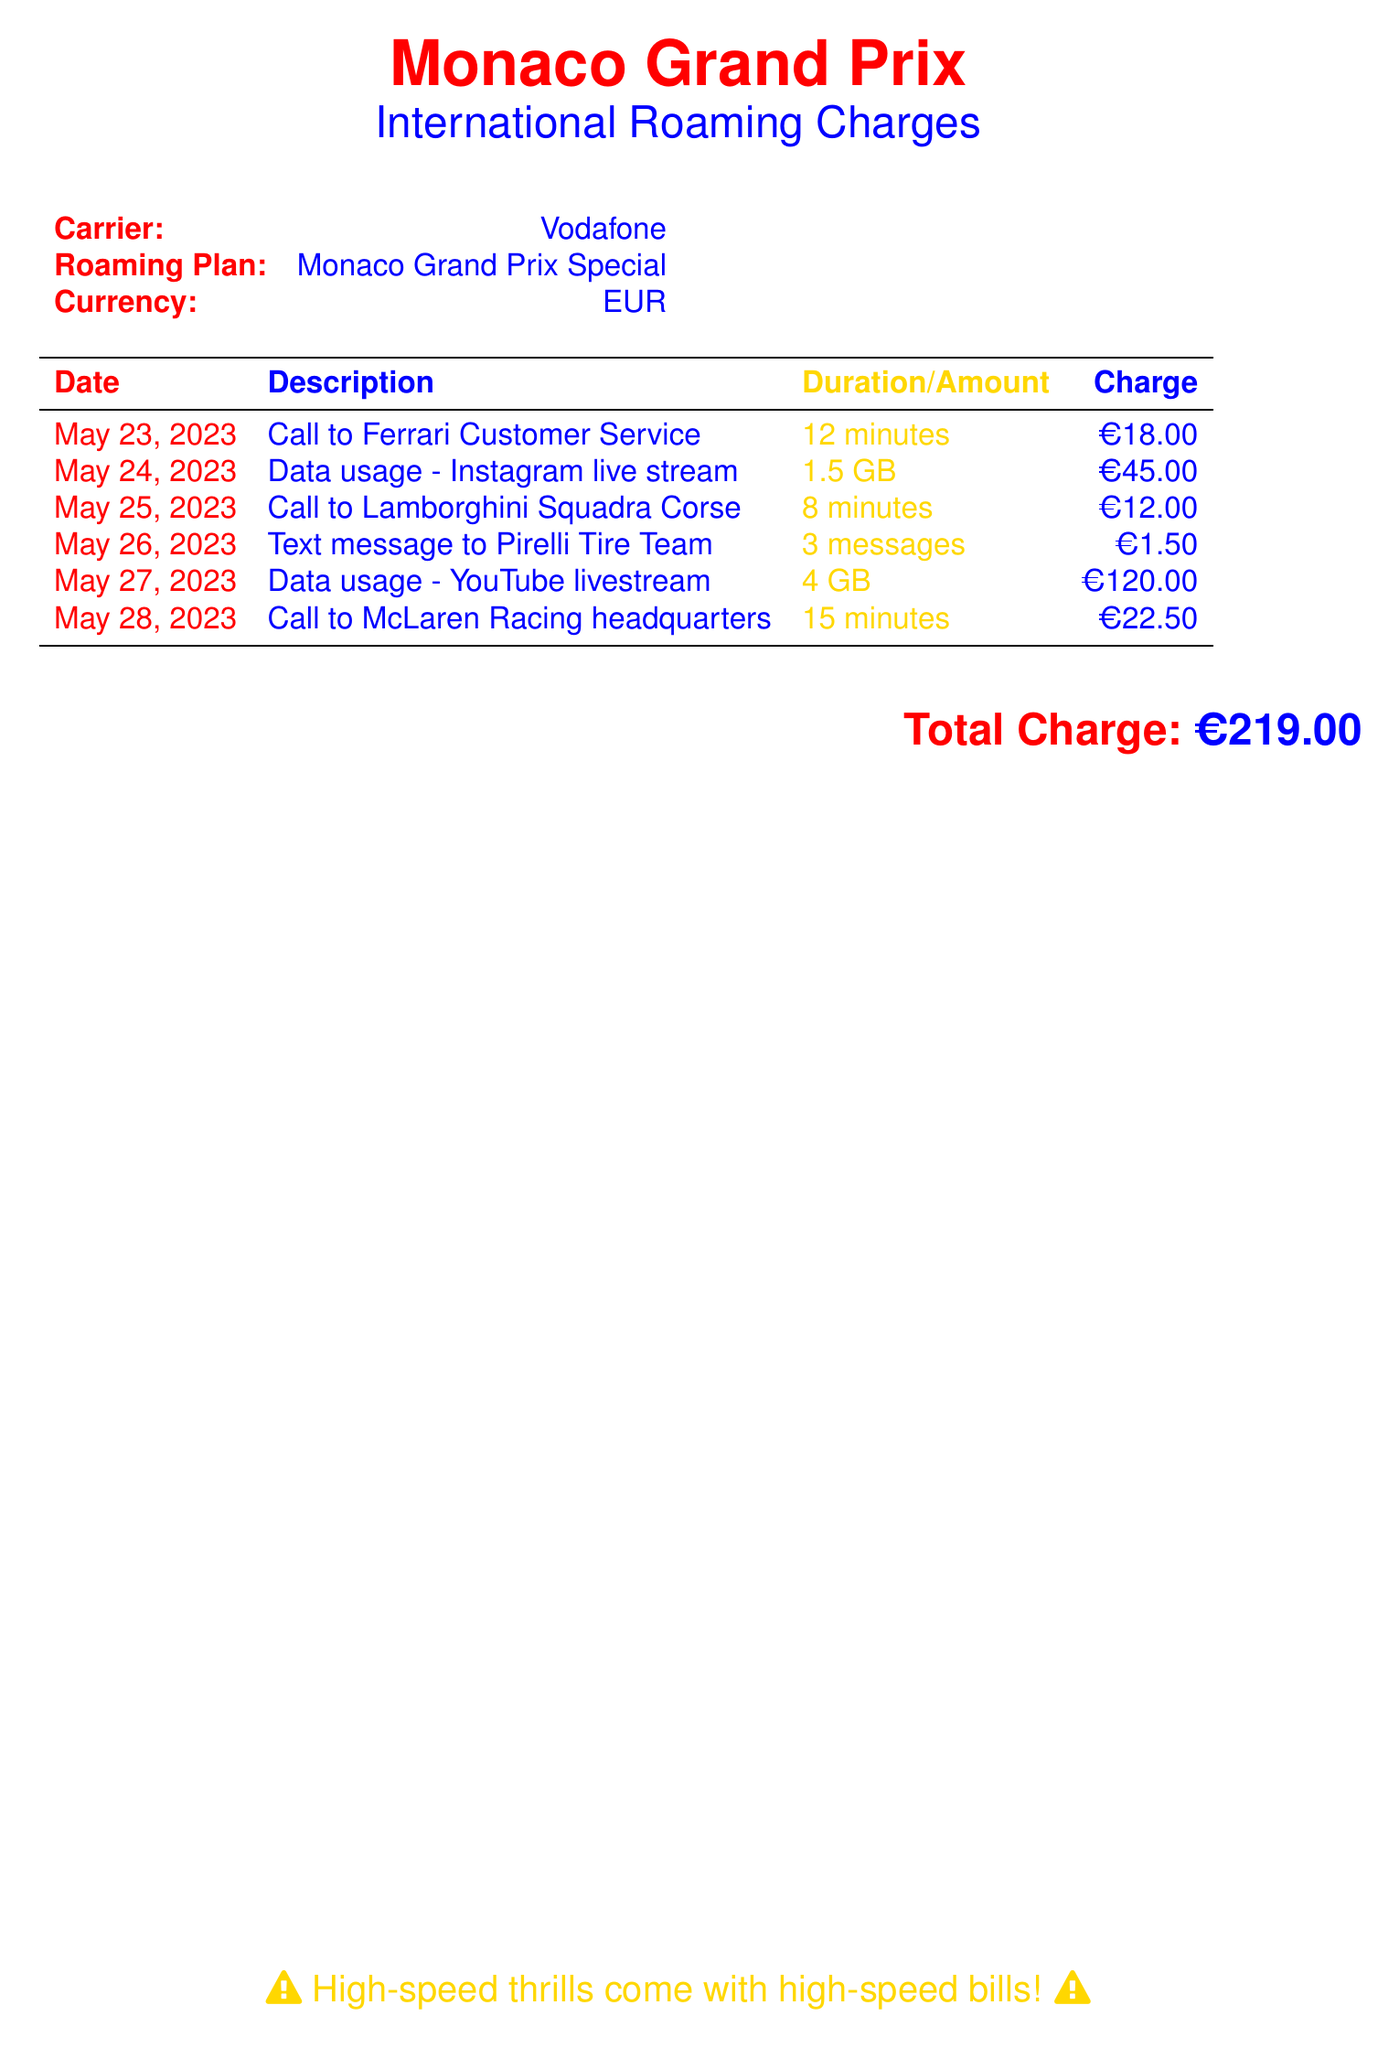What is the carrier? The carrier is explicitly stated in the document under the carrier heading.
Answer: Vodafone What is the total charge incurred? The total charge is presented at the bottom of the table.
Answer: €219.00 How many minutes were spent on the call to Ferrari Customer Service? The duration of the call to Ferrari Customer Service is listed next to its description in the table.
Answer: 12 minutes What was the data usage for the YouTube livestream? The amount of data used for the YouTube livestream is detailed in the description column of the table.
Answer: 4 GB What date was the call to Lamborghini Squadra Corse made? The date of the call to Lamborghini Squadra Corse is the date listed next to that entry in the table.
Answer: May 25, 2023 Which service had the highest charge? The entry with the highest charge is identifiable by comparing the charge amounts across all services listed in the document.
Answer: Data usage - YouTube livestream How many text messages were sent to the Pirelli Tire Team? The number of messages sent is specified alongside the description of the text message service in the table.
Answer: 3 messages What type of roaming plan was used? The roaming plan type is clearly stated in a designated field in the document.
Answer: Monaco Grand Prix Special What warning is included at the bottom of the document? The warning is presented in a highlighted, colored text at the end of the document.
Answer: High-speed thrills come with high-speed bills! 